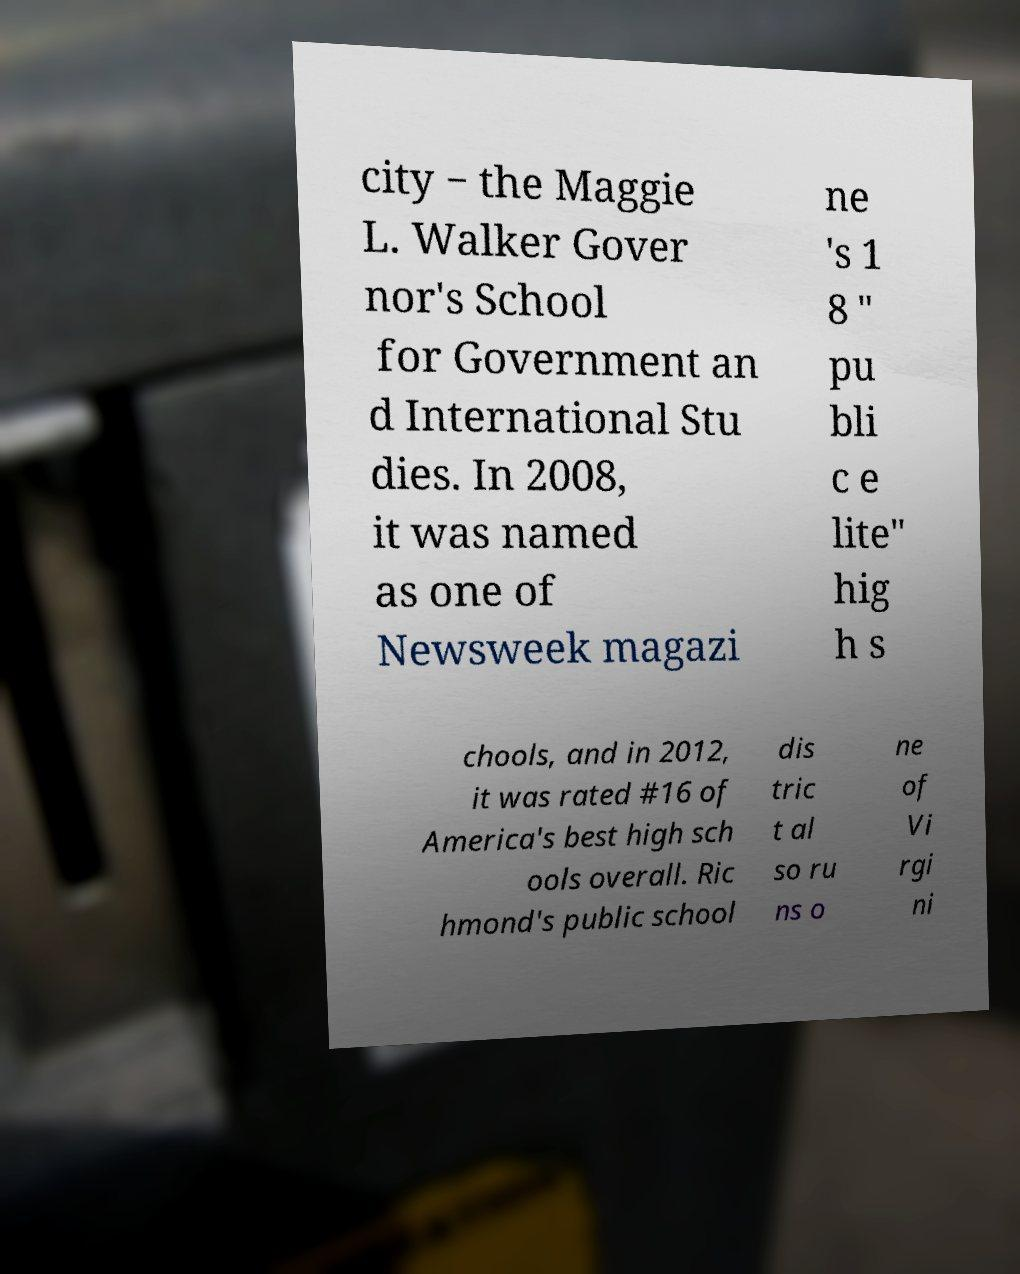Please read and relay the text visible in this image. What does it say? city − the Maggie L. Walker Gover nor's School for Government an d International Stu dies. In 2008, it was named as one of Newsweek magazi ne 's 1 8 " pu bli c e lite" hig h s chools, and in 2012, it was rated #16 of America's best high sch ools overall. Ric hmond's public school dis tric t al so ru ns o ne of Vi rgi ni 